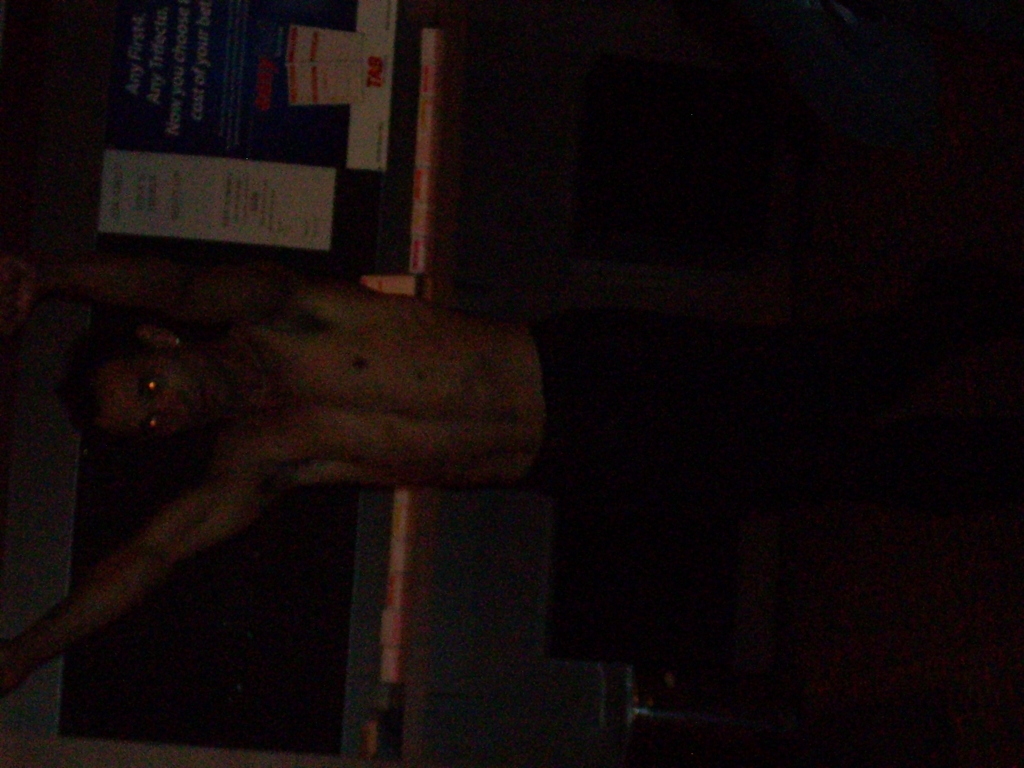What mood does this image convey, and how does it achieve that? The image conveys a mood of mystery and perhaps suspense, primarily due to the play of shadows and the obscured background. The lack of facial expression details, combined with the dark environment, emphasizes the enigmatic vibe of the photo. What could be happening just outside this frame? Given the limited information within the frame, it's open to interpretation. One might imagine that beyond the visible area, there could be a crowd watching a performance or an empty room suggesting solitude. The darkness obscures any contextual clues, leaving much to the viewer's imagination. 